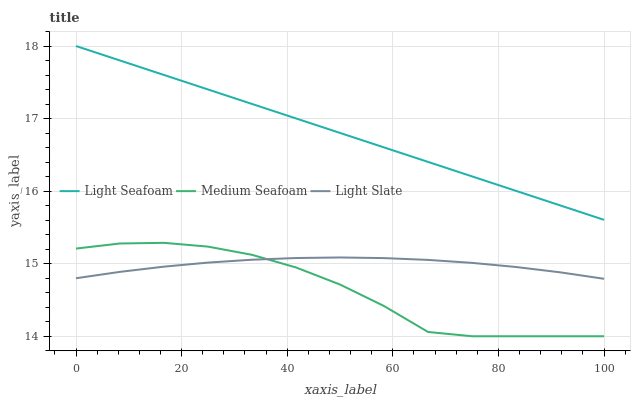Does Light Seafoam have the minimum area under the curve?
Answer yes or no. No. Does Medium Seafoam have the maximum area under the curve?
Answer yes or no. No. Is Medium Seafoam the smoothest?
Answer yes or no. No. Is Light Seafoam the roughest?
Answer yes or no. No. Does Light Seafoam have the lowest value?
Answer yes or no. No. Does Medium Seafoam have the highest value?
Answer yes or no. No. Is Light Slate less than Light Seafoam?
Answer yes or no. Yes. Is Light Seafoam greater than Medium Seafoam?
Answer yes or no. Yes. Does Light Slate intersect Light Seafoam?
Answer yes or no. No. 